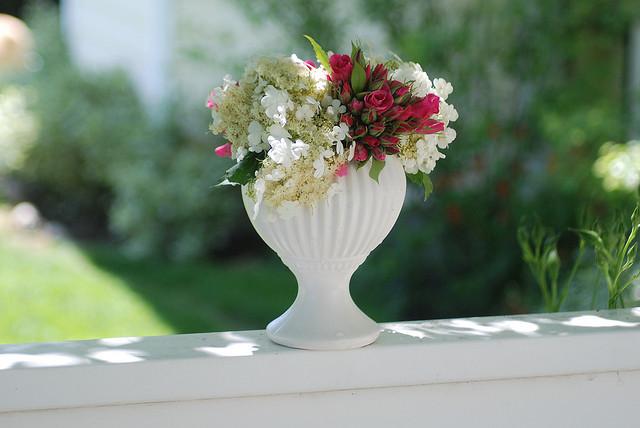Are there flowers in the vase?
Concise answer only. Yes. What is the vase sitting on?
Quick response, please. Railing. Is the sun to the right or left of this flower?
Write a very short answer. Left. Are the flowers open?
Be succinct. Yes. What color is the vase?
Write a very short answer. White. Are all the flowers white?
Keep it brief. No. 